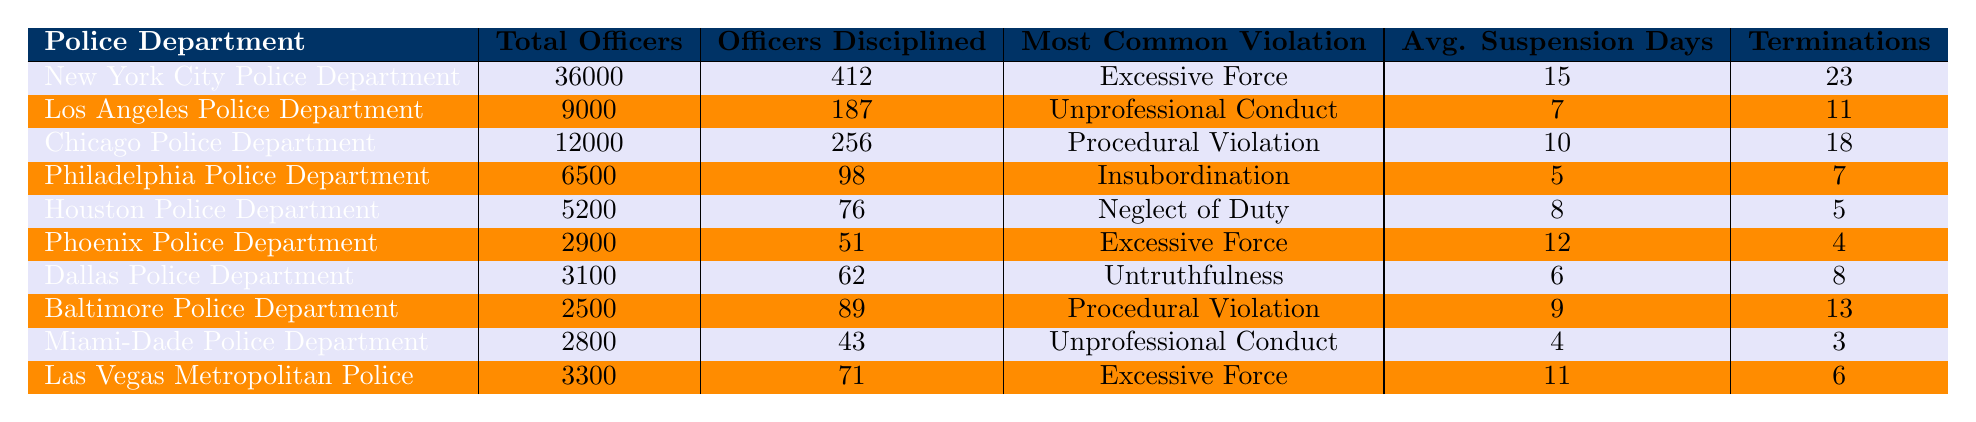What is the total number of officers in the New York City Police Department? The table indicates that the New York City Police Department has a total of 36,000 officers.
Answer: 36,000 Which police department had the highest number of officers disciplined? By looking at the "Officers Disciplined" column, the New York City Police Department has the highest number disciplined with 412 officers.
Answer: New York City Police Department What is the most common violation reported in the Chicago Police Department? The table reveals that the most common violation in the Chicago Police Department is a Procedural Violation.
Answer: Procedural Violation How many average suspension days are there for the officers in the Philadelphia Police Department? The table shows that the average suspension days for the Philadelphia Police Department is 5 days.
Answer: 5 Which department had the lowest number of terminations? In the "Terminations" column, the Miami-Dade Police Department has the lowest at 3 terminations.
Answer: Miami-Dade Police Department What is the average number of suspension days for officers across all departments? To find the average, sum the average suspension days (15 + 7 + 10 + 5 + 8 + 12 + 6 + 9 + 4 + 11 = 87) and divide by the number of departments (10): 87 / 10 = 8.7.
Answer: 8.7 Is excessive force the most common violation for more than one police department? The table shows that excessive force is the most common violation for New York City Police Department and Phoenix Police Department, making it true.
Answer: Yes Which police department has the most terminations in comparison to its size? To find out, calculate the ratio of terminations to total officers for each department. For example, New York (23/36000), Los Angeles (11/9000), etc. The highest ratio is 0.00255 for Los Angeles; therefore, it has the most terminations in comparison to its size.
Answer: Los Angeles Police Department How many total officers were disciplined in police departments that primarily reported “Excessive Force”? The departments reporting "Excessive Force" are New York City (412) and Phoenix (51). Adding these gives 412 + 51 = 463 officers disciplined.
Answer: 463 Which police department has the second-highest number of officers disciplined? By checking the "Officers Disciplined" column, Chicago Police Department has 256 officers disciplined, making it the second highest after New York.
Answer: Chicago Police Department 